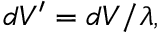Convert formula to latex. <formula><loc_0><loc_0><loc_500><loc_500>\begin{array} { r } { d V ^ { \prime } = d V / \lambda , } \end{array}</formula> 